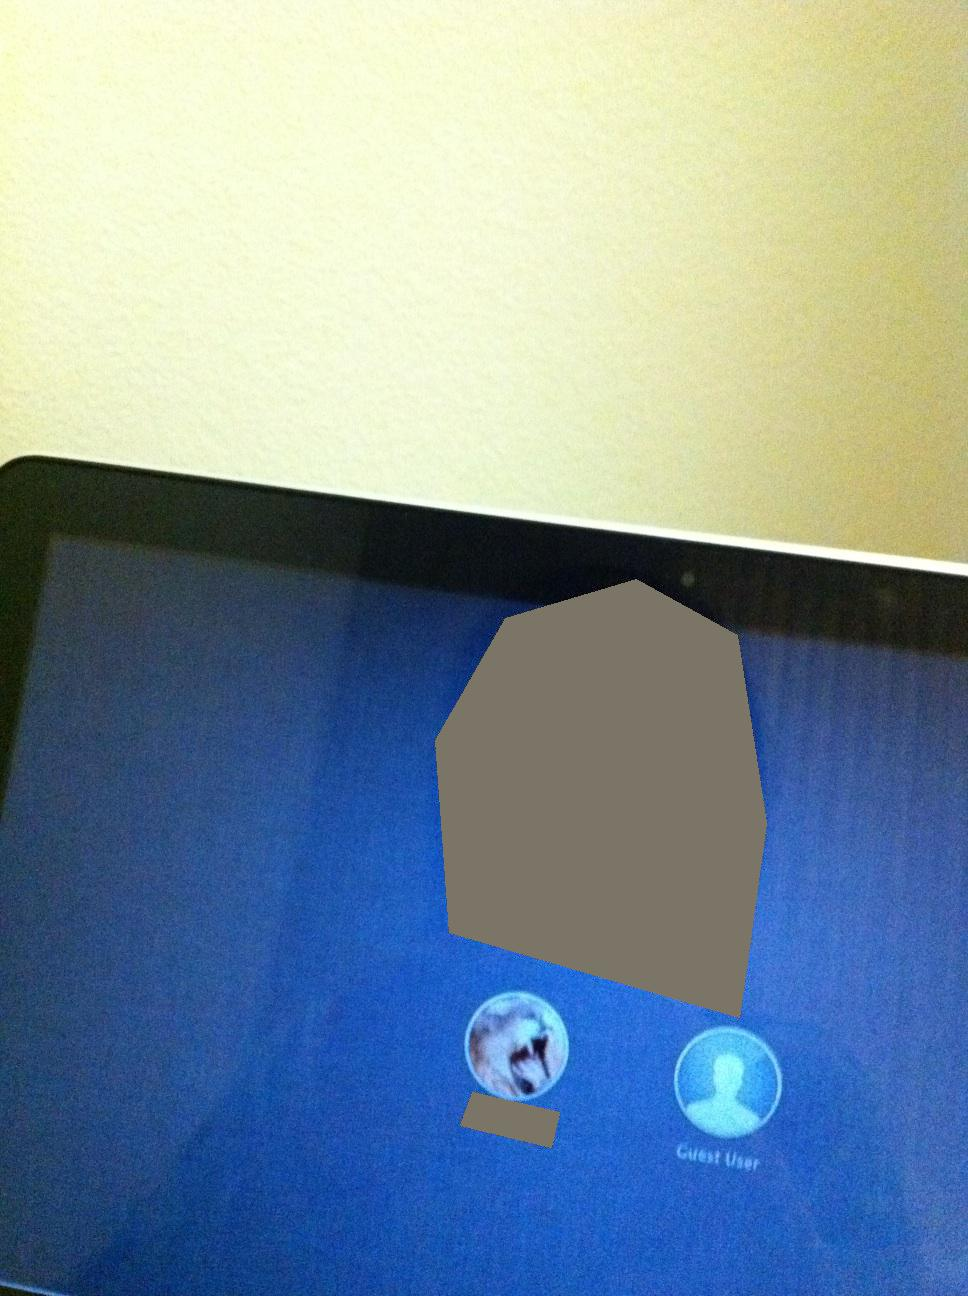Imagine the displayed options represent characters in a magical world. How would you describe these characters and their backstories? In a magical world, the first option represents 'Lyra', a sorceress with the ability to control the elements and communicate with mystical creatures. Her avatar depicts her loyal dragon companion. The 'Guest User' option signifies 'Aelan', an enigmatic wanderer who writes down the stories of the magical realm inhabitants. Aelan’s face is never shown, thereby depicting him with a generic icon that suggests his mysterious presence. 